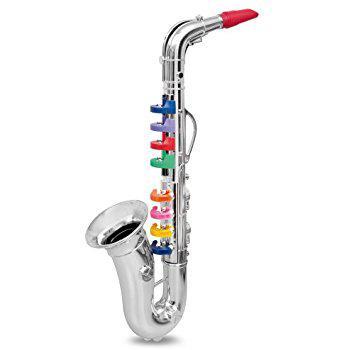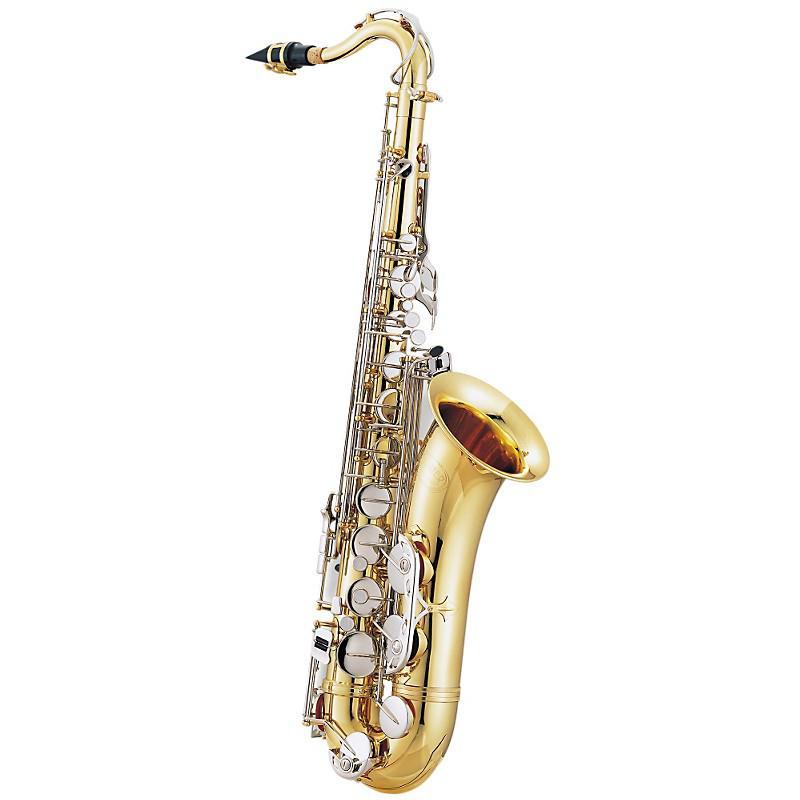The first image is the image on the left, the second image is the image on the right. Considering the images on both sides, is "In one image, a child wearing jeans is leaning back as he or she plays a saxophone." valid? Answer yes or no. No. The first image is the image on the left, the second image is the image on the right. Given the left and right images, does the statement "In one of the images there is a child playing a saxophone." hold true? Answer yes or no. No. 